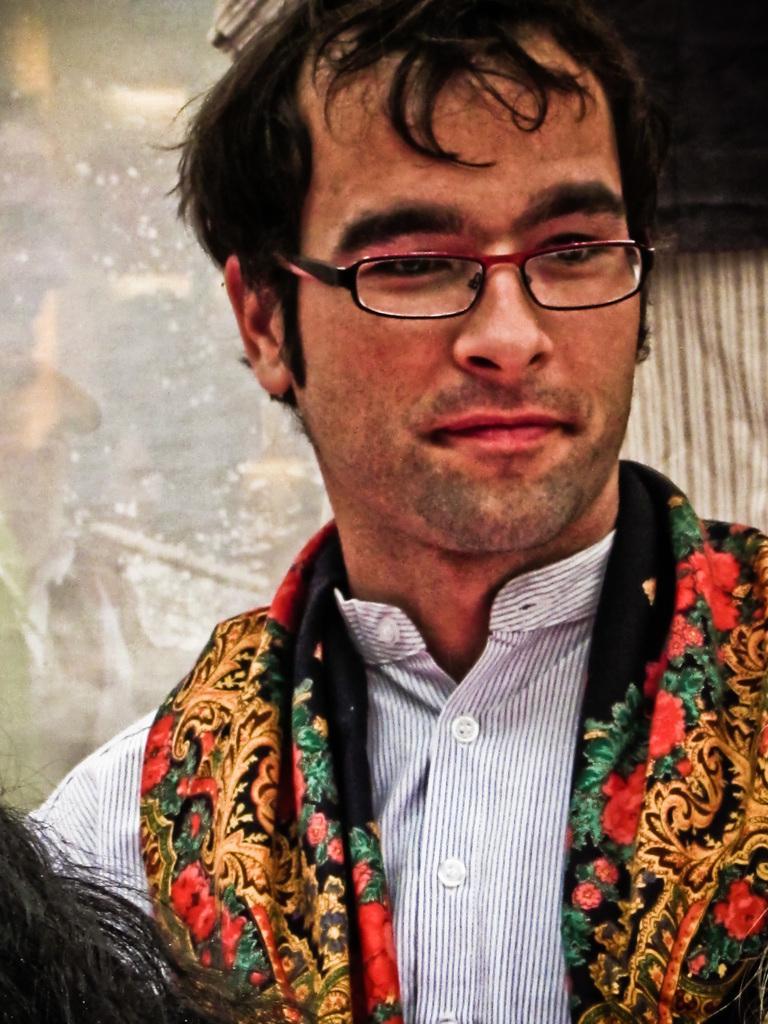Can you describe this image briefly? In this image we can see a man wearing the glasses and also the shirt. On the left we can see some person's hair and the background is not clear. 